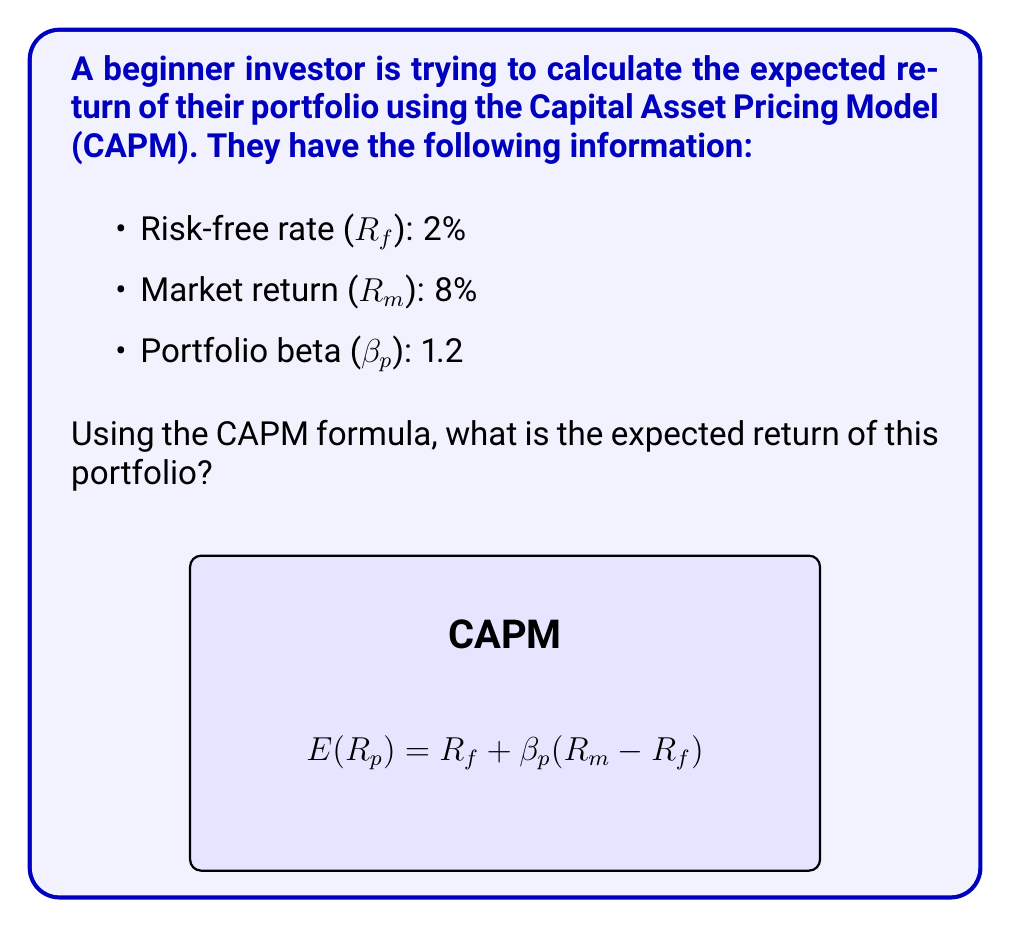Could you help me with this problem? Let's approach this step-by-step using the Capital Asset Pricing Model (CAPM) formula:

1) The CAPM formula is:
   $$E(R_p) = R_f + \beta_p(R_m - R_f)$$
   
   Where:
   - $E(R_p)$ is the expected return of the portfolio
   - $R_f$ is the risk-free rate
   - $\beta_p$ is the portfolio's beta
   - $R_m$ is the market return

2) We're given:
   - $R_f = 2\% = 0.02$
   - $R_m = 8\% = 0.08$
   - $\beta_p = 1.2$

3) Let's substitute these values into the formula:
   $$E(R_p) = 0.02 + 1.2(0.08 - 0.02)$$

4) First, calculate the market risk premium $(R_m - R_f)$:
   $$0.08 - 0.02 = 0.06$$

5) Now, multiply this by beta:
   $$1.2 \times 0.06 = 0.072$$

6) Finally, add the risk-free rate:
   $$0.02 + 0.072 = 0.092$$

7) Convert to a percentage:
   $$0.092 \times 100\% = 9.2\%$$

Therefore, the expected return of the portfolio is 9.2%.
Answer: 9.2% 